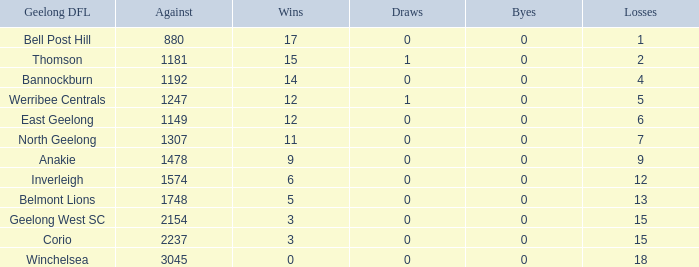What is the average of wins when the byes are less than 0? None. 